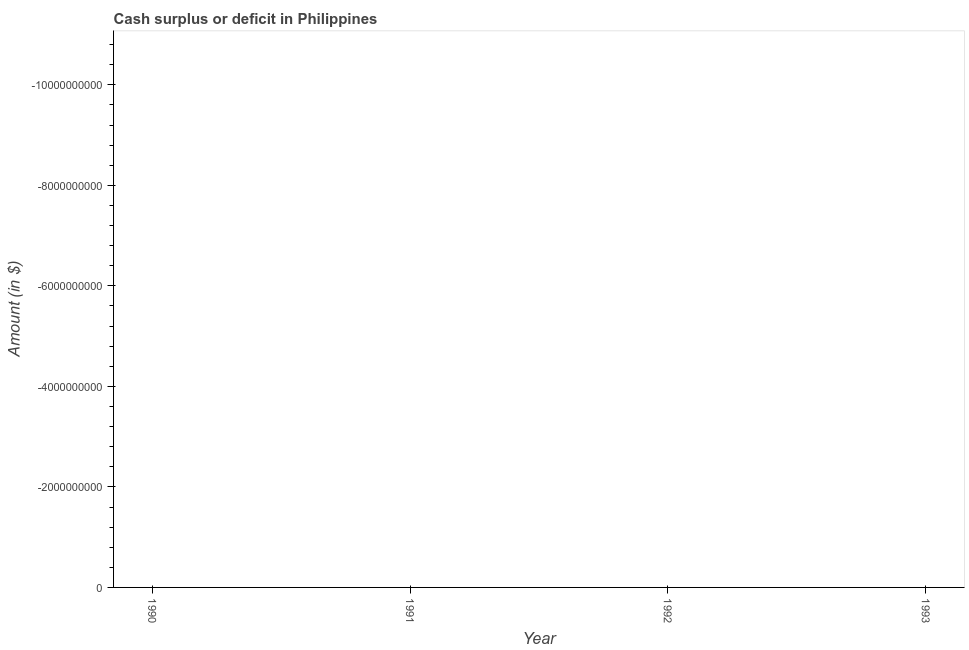What is the median cash surplus or deficit?
Your response must be concise. 0. How many lines are there?
Provide a succinct answer. 0. Are the values on the major ticks of Y-axis written in scientific E-notation?
Provide a short and direct response. No. Does the graph contain any zero values?
Make the answer very short. Yes. Does the graph contain grids?
Your answer should be very brief. No. What is the title of the graph?
Your response must be concise. Cash surplus or deficit in Philippines. What is the label or title of the Y-axis?
Keep it short and to the point. Amount (in $). What is the Amount (in $) in 1990?
Ensure brevity in your answer.  0. What is the Amount (in $) in 1992?
Your answer should be compact. 0. 